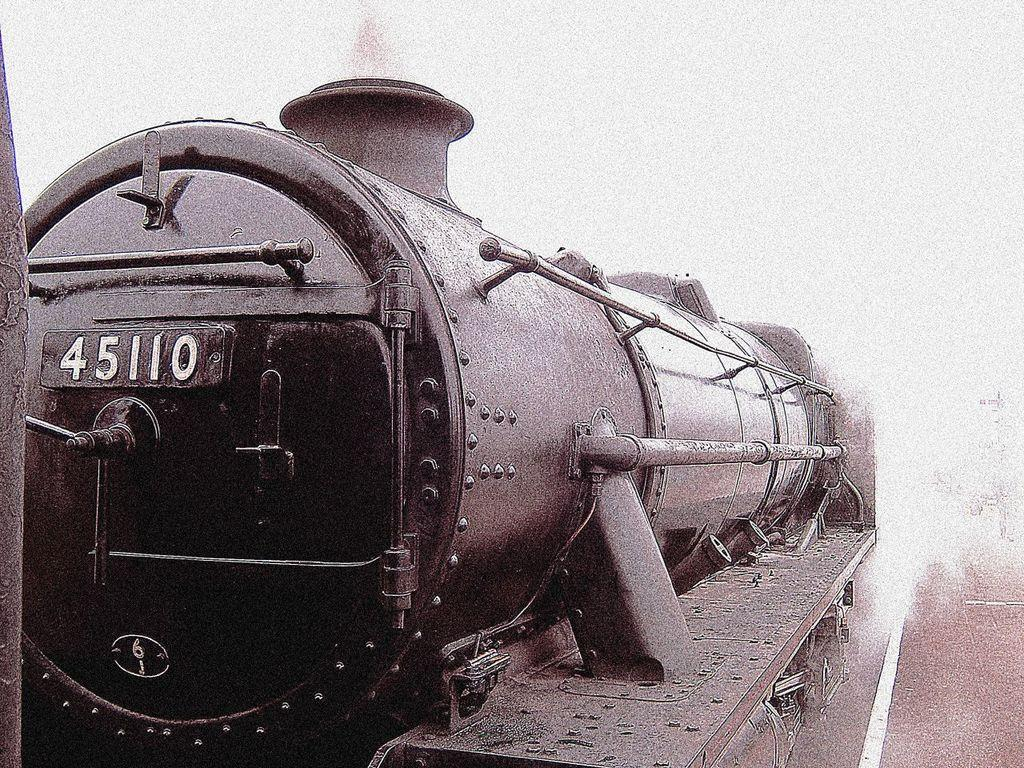What is the color scheme of the image? The image is black and white. What is the main subject of the image? There is a locomotive in the image. What color is the background of the image? The background of the image is white. How many pears are visible on the locomotive in the image? There are no pears present in the image; it features a black and white locomotive with a white background. 